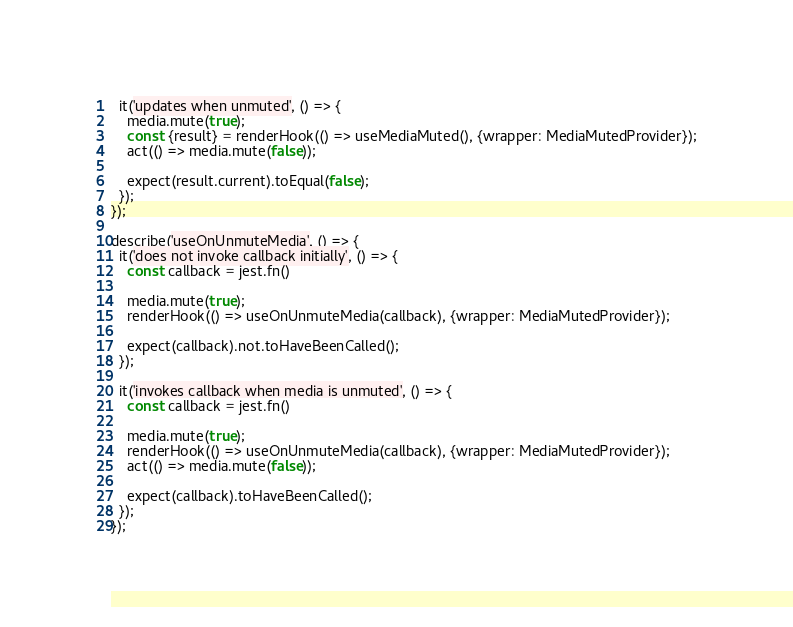<code> <loc_0><loc_0><loc_500><loc_500><_JavaScript_>  it('updates when unmuted', () => {
    media.mute(true);
    const {result} = renderHook(() => useMediaMuted(), {wrapper: MediaMutedProvider});
    act(() => media.mute(false));

    expect(result.current).toEqual(false);
  });
});

describe('useOnUnmuteMedia', () => {
  it('does not invoke callback initially', () => {
    const callback = jest.fn()

    media.mute(true);
    renderHook(() => useOnUnmuteMedia(callback), {wrapper: MediaMutedProvider});

    expect(callback).not.toHaveBeenCalled();
  });

  it('invokes callback when media is unmuted', () => {
    const callback = jest.fn()

    media.mute(true);
    renderHook(() => useOnUnmuteMedia(callback), {wrapper: MediaMutedProvider});
    act(() => media.mute(false));

    expect(callback).toHaveBeenCalled();
  });
});
</code> 